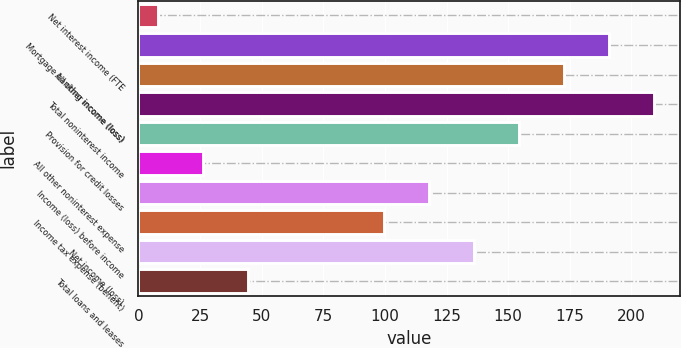Convert chart. <chart><loc_0><loc_0><loc_500><loc_500><bar_chart><fcel>Net interest income (FTE<fcel>Mortgage banking income (loss)<fcel>All other income (loss)<fcel>Total noninterest income<fcel>Provision for credit losses<fcel>All other noninterest expense<fcel>Income (loss) before income<fcel>Income tax expense (benefit)<fcel>Net income (loss)<fcel>Total loans and leases<nl><fcel>8<fcel>191<fcel>172.7<fcel>209.3<fcel>154.4<fcel>26.3<fcel>117.8<fcel>99.5<fcel>136.1<fcel>44.6<nl></chart> 